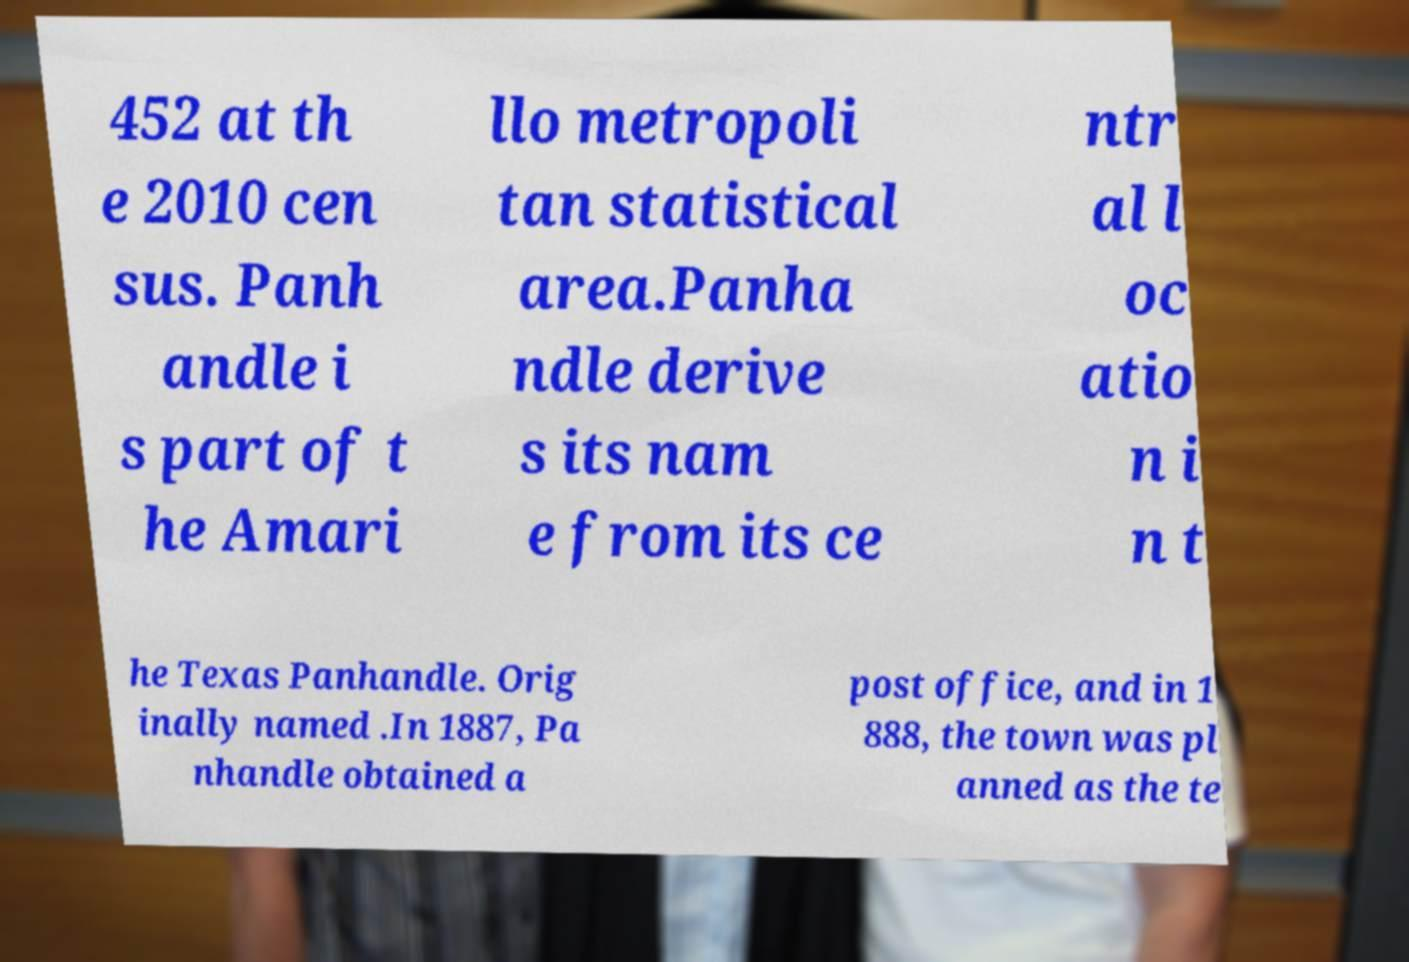Can you accurately transcribe the text from the provided image for me? 452 at th e 2010 cen sus. Panh andle i s part of t he Amari llo metropoli tan statistical area.Panha ndle derive s its nam e from its ce ntr al l oc atio n i n t he Texas Panhandle. Orig inally named .In 1887, Pa nhandle obtained a post office, and in 1 888, the town was pl anned as the te 